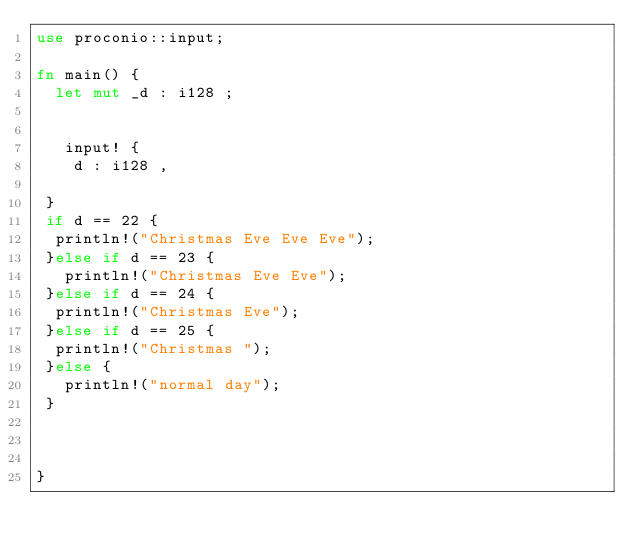Convert code to text. <code><loc_0><loc_0><loc_500><loc_500><_Rust_>use proconio::input;

fn main() {
  let mut _d : i128 ;
  

   input! {
    d : i128 ,
  
 }
 if d == 22 {
  println!("Christmas Eve Eve Eve");
 }else if d == 23 {
   println!("Christmas Eve Eve");
 }else if d == 24 {
  println!("Christmas Eve");
 }else if d == 25 {
  println!("Christmas ");
 }else {
   println!("normal day");
 }



}
</code> 